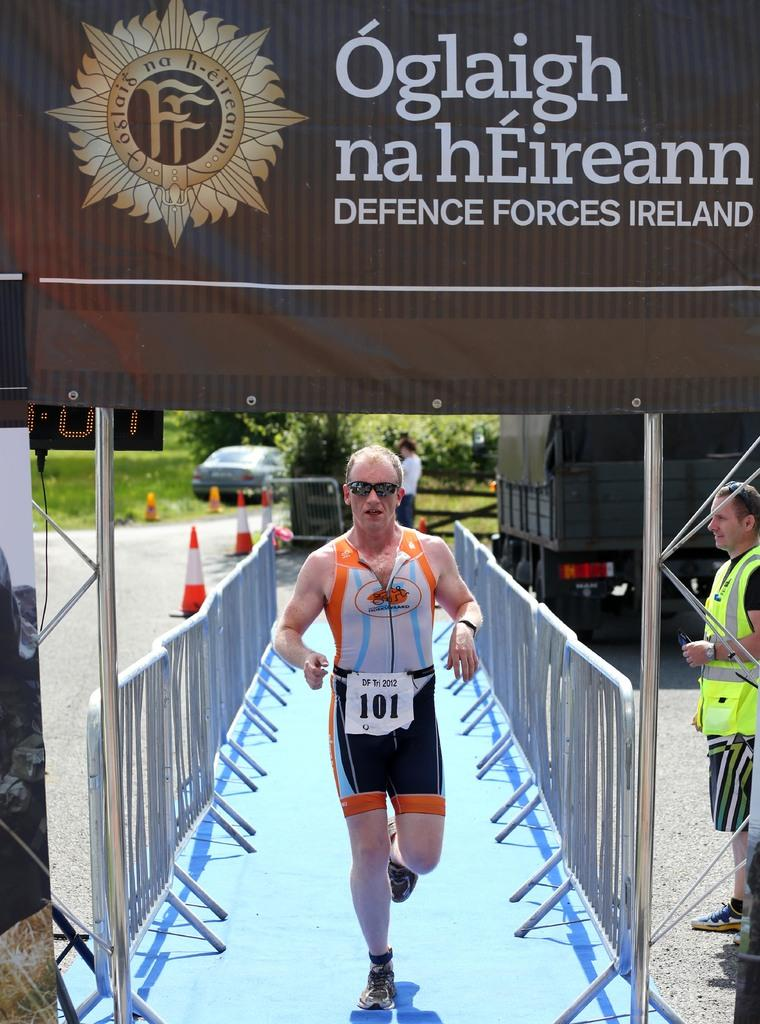<image>
Write a terse but informative summary of the picture. Runner number 101 goes between two sets of barriers on a blue rug. 